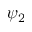Convert formula to latex. <formula><loc_0><loc_0><loc_500><loc_500>\psi _ { 2 }</formula> 